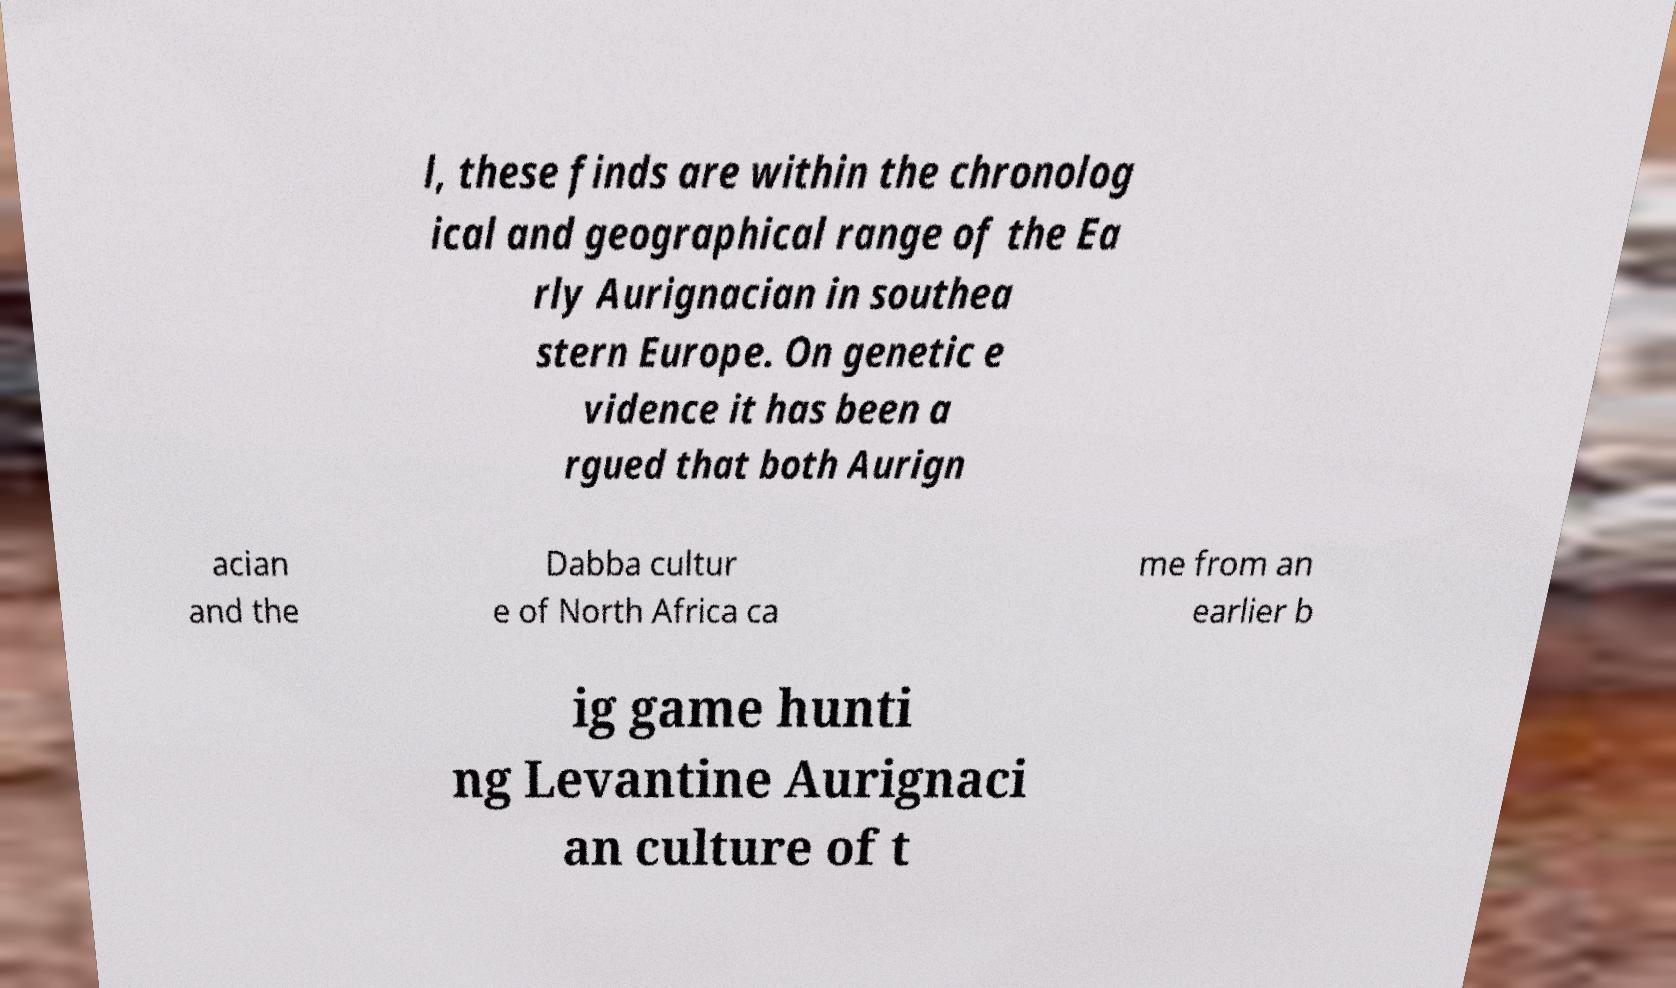For documentation purposes, I need the text within this image transcribed. Could you provide that? l, these finds are within the chronolog ical and geographical range of the Ea rly Aurignacian in southea stern Europe. On genetic e vidence it has been a rgued that both Aurign acian and the Dabba cultur e of North Africa ca me from an earlier b ig game hunti ng Levantine Aurignaci an culture of t 